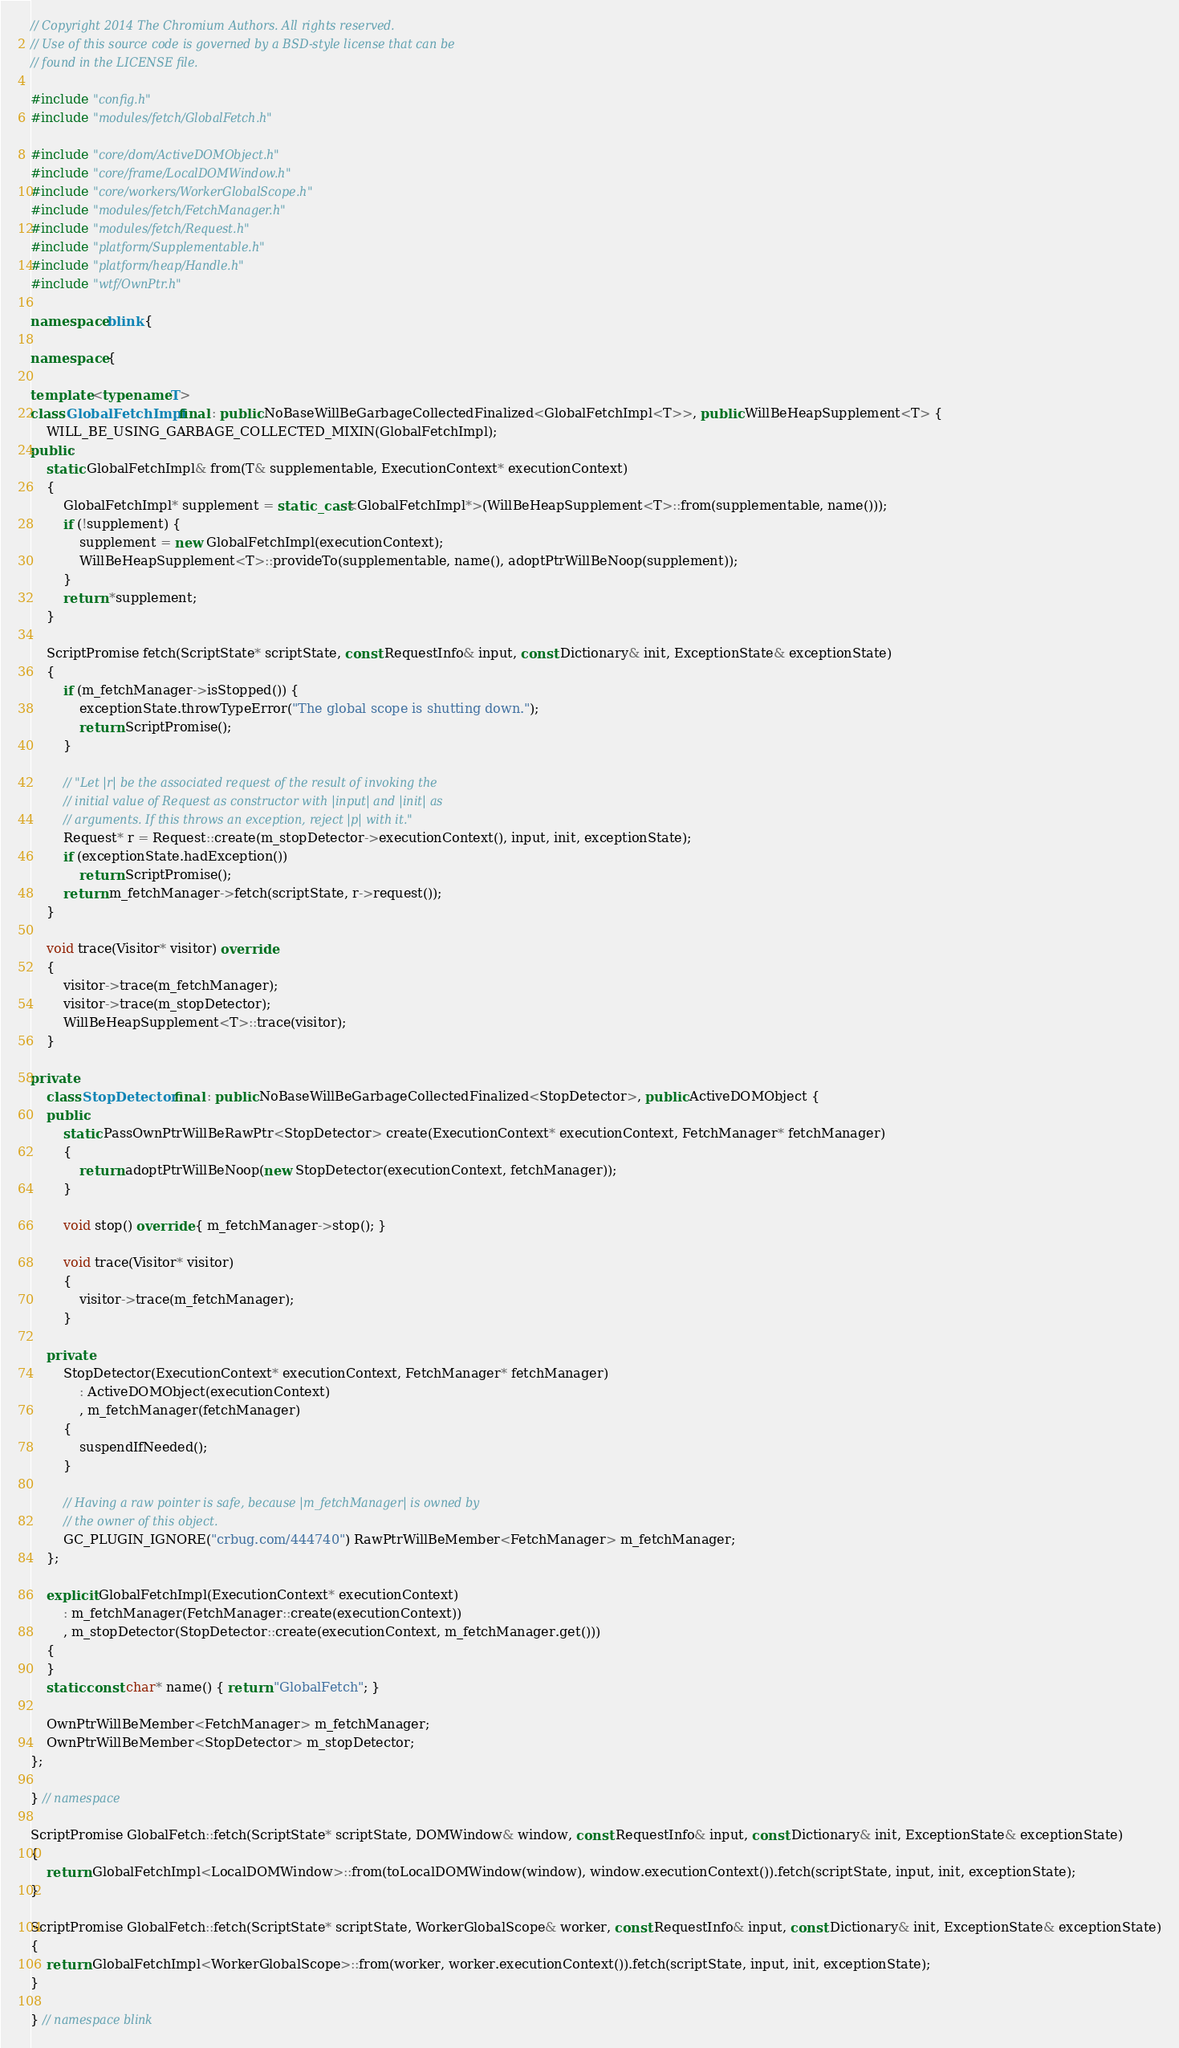<code> <loc_0><loc_0><loc_500><loc_500><_C++_>// Copyright 2014 The Chromium Authors. All rights reserved.
// Use of this source code is governed by a BSD-style license that can be
// found in the LICENSE file.

#include "config.h"
#include "modules/fetch/GlobalFetch.h"

#include "core/dom/ActiveDOMObject.h"
#include "core/frame/LocalDOMWindow.h"
#include "core/workers/WorkerGlobalScope.h"
#include "modules/fetch/FetchManager.h"
#include "modules/fetch/Request.h"
#include "platform/Supplementable.h"
#include "platform/heap/Handle.h"
#include "wtf/OwnPtr.h"

namespace blink {

namespace {

template <typename T>
class GlobalFetchImpl final : public NoBaseWillBeGarbageCollectedFinalized<GlobalFetchImpl<T>>, public WillBeHeapSupplement<T> {
    WILL_BE_USING_GARBAGE_COLLECTED_MIXIN(GlobalFetchImpl);
public:
    static GlobalFetchImpl& from(T& supplementable, ExecutionContext* executionContext)
    {
        GlobalFetchImpl* supplement = static_cast<GlobalFetchImpl*>(WillBeHeapSupplement<T>::from(supplementable, name()));
        if (!supplement) {
            supplement = new GlobalFetchImpl(executionContext);
            WillBeHeapSupplement<T>::provideTo(supplementable, name(), adoptPtrWillBeNoop(supplement));
        }
        return *supplement;
    }

    ScriptPromise fetch(ScriptState* scriptState, const RequestInfo& input, const Dictionary& init, ExceptionState& exceptionState)
    {
        if (m_fetchManager->isStopped()) {
            exceptionState.throwTypeError("The global scope is shutting down.");
            return ScriptPromise();
        }

        // "Let |r| be the associated request of the result of invoking the
        // initial value of Request as constructor with |input| and |init| as
        // arguments. If this throws an exception, reject |p| with it."
        Request* r = Request::create(m_stopDetector->executionContext(), input, init, exceptionState);
        if (exceptionState.hadException())
            return ScriptPromise();
        return m_fetchManager->fetch(scriptState, r->request());
    }

    void trace(Visitor* visitor) override
    {
        visitor->trace(m_fetchManager);
        visitor->trace(m_stopDetector);
        WillBeHeapSupplement<T>::trace(visitor);
    }

private:
    class StopDetector final : public NoBaseWillBeGarbageCollectedFinalized<StopDetector>, public ActiveDOMObject {
    public:
        static PassOwnPtrWillBeRawPtr<StopDetector> create(ExecutionContext* executionContext, FetchManager* fetchManager)
        {
            return adoptPtrWillBeNoop(new StopDetector(executionContext, fetchManager));
        }

        void stop() override { m_fetchManager->stop(); }

        void trace(Visitor* visitor)
        {
            visitor->trace(m_fetchManager);
        }

    private:
        StopDetector(ExecutionContext* executionContext, FetchManager* fetchManager)
            : ActiveDOMObject(executionContext)
            , m_fetchManager(fetchManager)
        {
            suspendIfNeeded();
        }

        // Having a raw pointer is safe, because |m_fetchManager| is owned by
        // the owner of this object.
        GC_PLUGIN_IGNORE("crbug.com/444740") RawPtrWillBeMember<FetchManager> m_fetchManager;
    };

    explicit GlobalFetchImpl(ExecutionContext* executionContext)
        : m_fetchManager(FetchManager::create(executionContext))
        , m_stopDetector(StopDetector::create(executionContext, m_fetchManager.get()))
    {
    }
    static const char* name() { return "GlobalFetch"; }

    OwnPtrWillBeMember<FetchManager> m_fetchManager;
    OwnPtrWillBeMember<StopDetector> m_stopDetector;
};

} // namespace

ScriptPromise GlobalFetch::fetch(ScriptState* scriptState, DOMWindow& window, const RequestInfo& input, const Dictionary& init, ExceptionState& exceptionState)
{
    return GlobalFetchImpl<LocalDOMWindow>::from(toLocalDOMWindow(window), window.executionContext()).fetch(scriptState, input, init, exceptionState);
}

ScriptPromise GlobalFetch::fetch(ScriptState* scriptState, WorkerGlobalScope& worker, const RequestInfo& input, const Dictionary& init, ExceptionState& exceptionState)
{
    return GlobalFetchImpl<WorkerGlobalScope>::from(worker, worker.executionContext()).fetch(scriptState, input, init, exceptionState);
}

} // namespace blink
</code> 